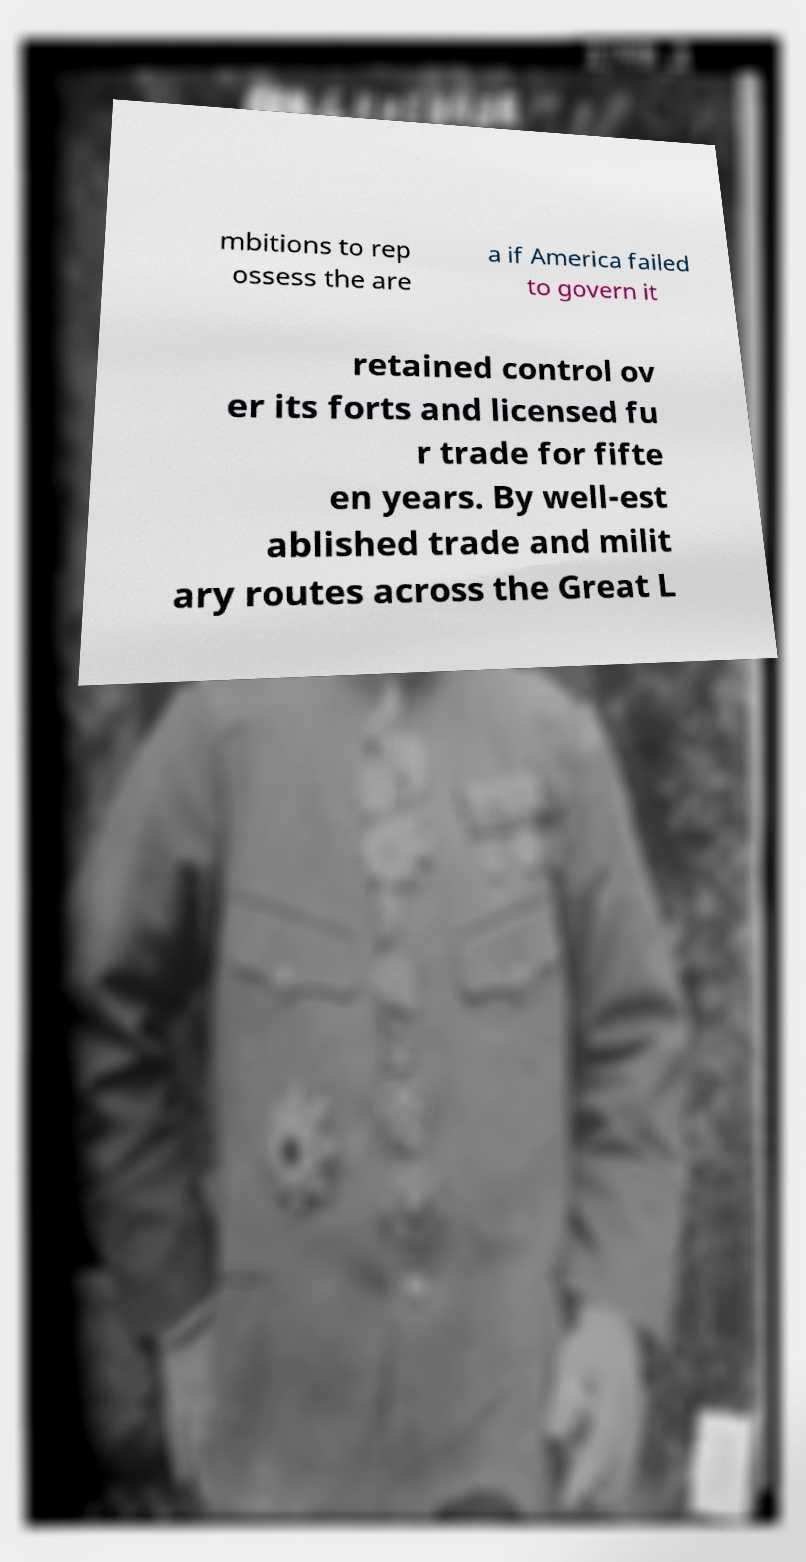Could you extract and type out the text from this image? mbitions to rep ossess the are a if America failed to govern it retained control ov er its forts and licensed fu r trade for fifte en years. By well-est ablished trade and milit ary routes across the Great L 